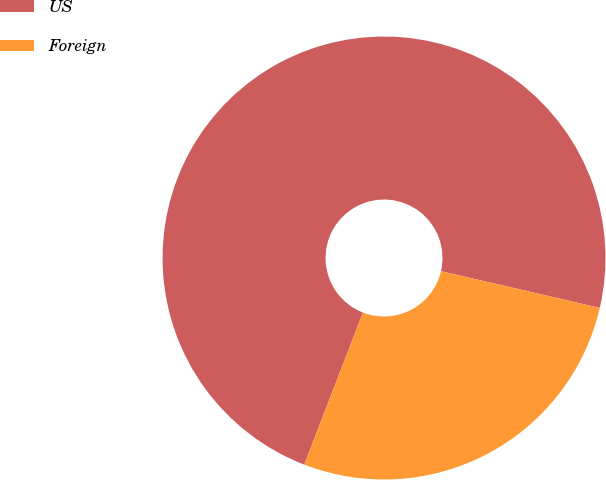<chart> <loc_0><loc_0><loc_500><loc_500><pie_chart><fcel>US<fcel>Foreign<nl><fcel>72.75%<fcel>27.25%<nl></chart> 